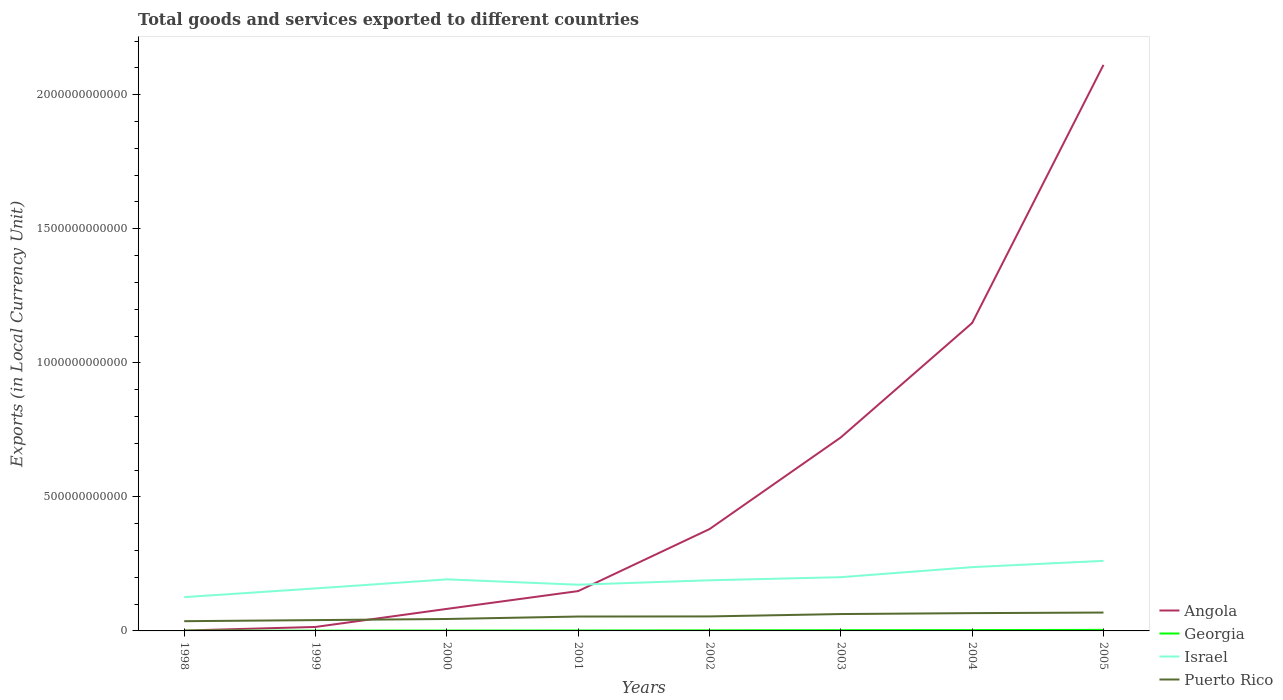Does the line corresponding to Georgia intersect with the line corresponding to Angola?
Provide a succinct answer. No. Across all years, what is the maximum Amount of goods and services exports in Israel?
Your answer should be very brief. 1.26e+11. In which year was the Amount of goods and services exports in Israel maximum?
Keep it short and to the point. 1998. What is the total Amount of goods and services exports in Angola in the graph?
Your response must be concise. -1.13e+12. What is the difference between the highest and the second highest Amount of goods and services exports in Georgia?
Make the answer very short. 3.10e+09. Is the Amount of goods and services exports in Georgia strictly greater than the Amount of goods and services exports in Israel over the years?
Give a very brief answer. Yes. What is the difference between two consecutive major ticks on the Y-axis?
Your answer should be very brief. 5.00e+11. Are the values on the major ticks of Y-axis written in scientific E-notation?
Give a very brief answer. No. Where does the legend appear in the graph?
Provide a short and direct response. Bottom right. What is the title of the graph?
Your answer should be very brief. Total goods and services exported to different countries. Does "Mexico" appear as one of the legend labels in the graph?
Provide a succinct answer. No. What is the label or title of the X-axis?
Offer a terse response. Years. What is the label or title of the Y-axis?
Offer a very short reply. Exports (in Local Currency Unit). What is the Exports (in Local Currency Unit) in Angola in 1998?
Provide a succinct answer. 1.44e+09. What is the Exports (in Local Currency Unit) of Georgia in 1998?
Ensure brevity in your answer.  8.27e+08. What is the Exports (in Local Currency Unit) of Israel in 1998?
Make the answer very short. 1.26e+11. What is the Exports (in Local Currency Unit) of Puerto Rico in 1998?
Offer a terse response. 3.63e+1. What is the Exports (in Local Currency Unit) of Angola in 1999?
Your response must be concise. 1.48e+1. What is the Exports (in Local Currency Unit) in Georgia in 1999?
Keep it short and to the point. 1.08e+09. What is the Exports (in Local Currency Unit) of Israel in 1999?
Make the answer very short. 1.59e+11. What is the Exports (in Local Currency Unit) in Puerto Rico in 1999?
Offer a terse response. 4.03e+1. What is the Exports (in Local Currency Unit) of Angola in 2000?
Provide a short and direct response. 8.22e+1. What is the Exports (in Local Currency Unit) of Georgia in 2000?
Ensure brevity in your answer.  1.39e+09. What is the Exports (in Local Currency Unit) of Israel in 2000?
Your answer should be very brief. 1.92e+11. What is the Exports (in Local Currency Unit) of Puerto Rico in 2000?
Ensure brevity in your answer.  4.45e+1. What is the Exports (in Local Currency Unit) of Angola in 2001?
Your answer should be very brief. 1.49e+11. What is the Exports (in Local Currency Unit) of Georgia in 2001?
Your answer should be compact. 1.63e+09. What is the Exports (in Local Currency Unit) in Israel in 2001?
Provide a short and direct response. 1.72e+11. What is the Exports (in Local Currency Unit) of Puerto Rico in 2001?
Provide a short and direct response. 5.37e+1. What is the Exports (in Local Currency Unit) in Angola in 2002?
Ensure brevity in your answer.  3.80e+11. What is the Exports (in Local Currency Unit) of Georgia in 2002?
Provide a short and direct response. 2.18e+09. What is the Exports (in Local Currency Unit) of Israel in 2002?
Give a very brief answer. 1.89e+11. What is the Exports (in Local Currency Unit) of Puerto Rico in 2002?
Offer a terse response. 5.41e+1. What is the Exports (in Local Currency Unit) in Angola in 2003?
Provide a succinct answer. 7.22e+11. What is the Exports (in Local Currency Unit) in Georgia in 2003?
Your answer should be compact. 2.73e+09. What is the Exports (in Local Currency Unit) in Israel in 2003?
Your answer should be very brief. 2.00e+11. What is the Exports (in Local Currency Unit) of Puerto Rico in 2003?
Offer a very short reply. 6.30e+1. What is the Exports (in Local Currency Unit) of Angola in 2004?
Provide a succinct answer. 1.15e+12. What is the Exports (in Local Currency Unit) of Georgia in 2004?
Keep it short and to the point. 3.10e+09. What is the Exports (in Local Currency Unit) in Israel in 2004?
Ensure brevity in your answer.  2.38e+11. What is the Exports (in Local Currency Unit) in Puerto Rico in 2004?
Keep it short and to the point. 6.64e+1. What is the Exports (in Local Currency Unit) in Angola in 2005?
Provide a short and direct response. 2.11e+12. What is the Exports (in Local Currency Unit) in Georgia in 2005?
Keep it short and to the point. 3.92e+09. What is the Exports (in Local Currency Unit) in Israel in 2005?
Offer a terse response. 2.61e+11. What is the Exports (in Local Currency Unit) in Puerto Rico in 2005?
Give a very brief answer. 6.86e+1. Across all years, what is the maximum Exports (in Local Currency Unit) of Angola?
Keep it short and to the point. 2.11e+12. Across all years, what is the maximum Exports (in Local Currency Unit) in Georgia?
Ensure brevity in your answer.  3.92e+09. Across all years, what is the maximum Exports (in Local Currency Unit) in Israel?
Your response must be concise. 2.61e+11. Across all years, what is the maximum Exports (in Local Currency Unit) of Puerto Rico?
Make the answer very short. 6.86e+1. Across all years, what is the minimum Exports (in Local Currency Unit) in Angola?
Ensure brevity in your answer.  1.44e+09. Across all years, what is the minimum Exports (in Local Currency Unit) in Georgia?
Provide a succinct answer. 8.27e+08. Across all years, what is the minimum Exports (in Local Currency Unit) in Israel?
Your answer should be very brief. 1.26e+11. Across all years, what is the minimum Exports (in Local Currency Unit) of Puerto Rico?
Offer a very short reply. 3.63e+1. What is the total Exports (in Local Currency Unit) of Angola in the graph?
Make the answer very short. 4.61e+12. What is the total Exports (in Local Currency Unit) of Georgia in the graph?
Offer a terse response. 1.69e+1. What is the total Exports (in Local Currency Unit) in Israel in the graph?
Give a very brief answer. 1.54e+12. What is the total Exports (in Local Currency Unit) of Puerto Rico in the graph?
Make the answer very short. 4.27e+11. What is the difference between the Exports (in Local Currency Unit) in Angola in 1998 and that in 1999?
Offer a very short reply. -1.34e+1. What is the difference between the Exports (in Local Currency Unit) in Georgia in 1998 and that in 1999?
Provide a short and direct response. -2.54e+08. What is the difference between the Exports (in Local Currency Unit) in Israel in 1998 and that in 1999?
Give a very brief answer. -3.25e+1. What is the difference between the Exports (in Local Currency Unit) in Puerto Rico in 1998 and that in 1999?
Offer a terse response. -4.00e+09. What is the difference between the Exports (in Local Currency Unit) of Angola in 1998 and that in 2000?
Provide a succinct answer. -8.07e+1. What is the difference between the Exports (in Local Currency Unit) in Georgia in 1998 and that in 2000?
Ensure brevity in your answer.  -5.63e+08. What is the difference between the Exports (in Local Currency Unit) of Israel in 1998 and that in 2000?
Ensure brevity in your answer.  -6.62e+1. What is the difference between the Exports (in Local Currency Unit) of Puerto Rico in 1998 and that in 2000?
Provide a short and direct response. -8.22e+09. What is the difference between the Exports (in Local Currency Unit) in Angola in 1998 and that in 2001?
Keep it short and to the point. -1.47e+11. What is the difference between the Exports (in Local Currency Unit) in Georgia in 1998 and that in 2001?
Make the answer very short. -8.06e+08. What is the difference between the Exports (in Local Currency Unit) in Israel in 1998 and that in 2001?
Your answer should be compact. -4.63e+1. What is the difference between the Exports (in Local Currency Unit) in Puerto Rico in 1998 and that in 2001?
Offer a terse response. -1.74e+1. What is the difference between the Exports (in Local Currency Unit) of Angola in 1998 and that in 2002?
Make the answer very short. -3.78e+11. What is the difference between the Exports (in Local Currency Unit) of Georgia in 1998 and that in 2002?
Offer a terse response. -1.35e+09. What is the difference between the Exports (in Local Currency Unit) of Israel in 1998 and that in 2002?
Keep it short and to the point. -6.29e+1. What is the difference between the Exports (in Local Currency Unit) in Puerto Rico in 1998 and that in 2002?
Your response must be concise. -1.78e+1. What is the difference between the Exports (in Local Currency Unit) in Angola in 1998 and that in 2003?
Offer a terse response. -7.20e+11. What is the difference between the Exports (in Local Currency Unit) in Georgia in 1998 and that in 2003?
Ensure brevity in your answer.  -1.90e+09. What is the difference between the Exports (in Local Currency Unit) of Israel in 1998 and that in 2003?
Provide a succinct answer. -7.44e+1. What is the difference between the Exports (in Local Currency Unit) in Puerto Rico in 1998 and that in 2003?
Your answer should be very brief. -2.67e+1. What is the difference between the Exports (in Local Currency Unit) of Angola in 1998 and that in 2004?
Make the answer very short. -1.15e+12. What is the difference between the Exports (in Local Currency Unit) in Georgia in 1998 and that in 2004?
Make the answer very short. -2.27e+09. What is the difference between the Exports (in Local Currency Unit) of Israel in 1998 and that in 2004?
Provide a succinct answer. -1.12e+11. What is the difference between the Exports (in Local Currency Unit) in Puerto Rico in 1998 and that in 2004?
Offer a very short reply. -3.01e+1. What is the difference between the Exports (in Local Currency Unit) of Angola in 1998 and that in 2005?
Your answer should be compact. -2.11e+12. What is the difference between the Exports (in Local Currency Unit) in Georgia in 1998 and that in 2005?
Your answer should be very brief. -3.10e+09. What is the difference between the Exports (in Local Currency Unit) in Israel in 1998 and that in 2005?
Keep it short and to the point. -1.35e+11. What is the difference between the Exports (in Local Currency Unit) in Puerto Rico in 1998 and that in 2005?
Offer a terse response. -3.23e+1. What is the difference between the Exports (in Local Currency Unit) of Angola in 1999 and that in 2000?
Provide a short and direct response. -6.73e+1. What is the difference between the Exports (in Local Currency Unit) in Georgia in 1999 and that in 2000?
Your answer should be compact. -3.09e+08. What is the difference between the Exports (in Local Currency Unit) of Israel in 1999 and that in 2000?
Offer a terse response. -3.37e+1. What is the difference between the Exports (in Local Currency Unit) in Puerto Rico in 1999 and that in 2000?
Give a very brief answer. -4.22e+09. What is the difference between the Exports (in Local Currency Unit) of Angola in 1999 and that in 2001?
Offer a terse response. -1.34e+11. What is the difference between the Exports (in Local Currency Unit) of Georgia in 1999 and that in 2001?
Your answer should be very brief. -5.52e+08. What is the difference between the Exports (in Local Currency Unit) in Israel in 1999 and that in 2001?
Give a very brief answer. -1.38e+1. What is the difference between the Exports (in Local Currency Unit) in Puerto Rico in 1999 and that in 2001?
Make the answer very short. -1.34e+1. What is the difference between the Exports (in Local Currency Unit) of Angola in 1999 and that in 2002?
Offer a terse response. -3.65e+11. What is the difference between the Exports (in Local Currency Unit) of Georgia in 1999 and that in 2002?
Your response must be concise. -1.10e+09. What is the difference between the Exports (in Local Currency Unit) in Israel in 1999 and that in 2002?
Make the answer very short. -3.03e+1. What is the difference between the Exports (in Local Currency Unit) of Puerto Rico in 1999 and that in 2002?
Offer a very short reply. -1.38e+1. What is the difference between the Exports (in Local Currency Unit) of Angola in 1999 and that in 2003?
Ensure brevity in your answer.  -7.07e+11. What is the difference between the Exports (in Local Currency Unit) in Georgia in 1999 and that in 2003?
Ensure brevity in your answer.  -1.65e+09. What is the difference between the Exports (in Local Currency Unit) of Israel in 1999 and that in 2003?
Keep it short and to the point. -4.19e+1. What is the difference between the Exports (in Local Currency Unit) of Puerto Rico in 1999 and that in 2003?
Your response must be concise. -2.27e+1. What is the difference between the Exports (in Local Currency Unit) in Angola in 1999 and that in 2004?
Ensure brevity in your answer.  -1.13e+12. What is the difference between the Exports (in Local Currency Unit) in Georgia in 1999 and that in 2004?
Keep it short and to the point. -2.02e+09. What is the difference between the Exports (in Local Currency Unit) of Israel in 1999 and that in 2004?
Your answer should be compact. -7.94e+1. What is the difference between the Exports (in Local Currency Unit) of Puerto Rico in 1999 and that in 2004?
Offer a very short reply. -2.61e+1. What is the difference between the Exports (in Local Currency Unit) in Angola in 1999 and that in 2005?
Your answer should be compact. -2.10e+12. What is the difference between the Exports (in Local Currency Unit) of Georgia in 1999 and that in 2005?
Offer a very short reply. -2.84e+09. What is the difference between the Exports (in Local Currency Unit) in Israel in 1999 and that in 2005?
Ensure brevity in your answer.  -1.03e+11. What is the difference between the Exports (in Local Currency Unit) of Puerto Rico in 1999 and that in 2005?
Keep it short and to the point. -2.83e+1. What is the difference between the Exports (in Local Currency Unit) in Angola in 2000 and that in 2001?
Give a very brief answer. -6.64e+1. What is the difference between the Exports (in Local Currency Unit) in Georgia in 2000 and that in 2001?
Provide a short and direct response. -2.43e+08. What is the difference between the Exports (in Local Currency Unit) in Israel in 2000 and that in 2001?
Make the answer very short. 1.99e+1. What is the difference between the Exports (in Local Currency Unit) of Puerto Rico in 2000 and that in 2001?
Offer a terse response. -9.18e+09. What is the difference between the Exports (in Local Currency Unit) of Angola in 2000 and that in 2002?
Make the answer very short. -2.98e+11. What is the difference between the Exports (in Local Currency Unit) in Georgia in 2000 and that in 2002?
Your response must be concise. -7.90e+08. What is the difference between the Exports (in Local Currency Unit) in Israel in 2000 and that in 2002?
Your response must be concise. 3.37e+09. What is the difference between the Exports (in Local Currency Unit) in Puerto Rico in 2000 and that in 2002?
Ensure brevity in your answer.  -9.58e+09. What is the difference between the Exports (in Local Currency Unit) of Angola in 2000 and that in 2003?
Make the answer very short. -6.40e+11. What is the difference between the Exports (in Local Currency Unit) in Georgia in 2000 and that in 2003?
Keep it short and to the point. -1.34e+09. What is the difference between the Exports (in Local Currency Unit) in Israel in 2000 and that in 2003?
Make the answer very short. -8.22e+09. What is the difference between the Exports (in Local Currency Unit) in Puerto Rico in 2000 and that in 2003?
Ensure brevity in your answer.  -1.84e+1. What is the difference between the Exports (in Local Currency Unit) of Angola in 2000 and that in 2004?
Your response must be concise. -1.07e+12. What is the difference between the Exports (in Local Currency Unit) of Georgia in 2000 and that in 2004?
Keep it short and to the point. -1.71e+09. What is the difference between the Exports (in Local Currency Unit) of Israel in 2000 and that in 2004?
Your response must be concise. -4.56e+1. What is the difference between the Exports (in Local Currency Unit) of Puerto Rico in 2000 and that in 2004?
Ensure brevity in your answer.  -2.19e+1. What is the difference between the Exports (in Local Currency Unit) of Angola in 2000 and that in 2005?
Provide a short and direct response. -2.03e+12. What is the difference between the Exports (in Local Currency Unit) in Georgia in 2000 and that in 2005?
Your response must be concise. -2.53e+09. What is the difference between the Exports (in Local Currency Unit) of Israel in 2000 and that in 2005?
Offer a terse response. -6.91e+1. What is the difference between the Exports (in Local Currency Unit) in Puerto Rico in 2000 and that in 2005?
Keep it short and to the point. -2.40e+1. What is the difference between the Exports (in Local Currency Unit) in Angola in 2001 and that in 2002?
Make the answer very short. -2.31e+11. What is the difference between the Exports (in Local Currency Unit) in Georgia in 2001 and that in 2002?
Your response must be concise. -5.47e+08. What is the difference between the Exports (in Local Currency Unit) in Israel in 2001 and that in 2002?
Offer a terse response. -1.66e+1. What is the difference between the Exports (in Local Currency Unit) in Puerto Rico in 2001 and that in 2002?
Give a very brief answer. -3.95e+08. What is the difference between the Exports (in Local Currency Unit) in Angola in 2001 and that in 2003?
Make the answer very short. -5.73e+11. What is the difference between the Exports (in Local Currency Unit) of Georgia in 2001 and that in 2003?
Make the answer very short. -1.09e+09. What is the difference between the Exports (in Local Currency Unit) of Israel in 2001 and that in 2003?
Your response must be concise. -2.82e+1. What is the difference between the Exports (in Local Currency Unit) in Puerto Rico in 2001 and that in 2003?
Offer a terse response. -9.26e+09. What is the difference between the Exports (in Local Currency Unit) in Angola in 2001 and that in 2004?
Provide a short and direct response. -1.00e+12. What is the difference between the Exports (in Local Currency Unit) in Georgia in 2001 and that in 2004?
Provide a succinct answer. -1.47e+09. What is the difference between the Exports (in Local Currency Unit) of Israel in 2001 and that in 2004?
Offer a very short reply. -6.56e+1. What is the difference between the Exports (in Local Currency Unit) of Puerto Rico in 2001 and that in 2004?
Give a very brief answer. -1.27e+1. What is the difference between the Exports (in Local Currency Unit) of Angola in 2001 and that in 2005?
Ensure brevity in your answer.  -1.96e+12. What is the difference between the Exports (in Local Currency Unit) in Georgia in 2001 and that in 2005?
Make the answer very short. -2.29e+09. What is the difference between the Exports (in Local Currency Unit) of Israel in 2001 and that in 2005?
Provide a short and direct response. -8.90e+1. What is the difference between the Exports (in Local Currency Unit) of Puerto Rico in 2001 and that in 2005?
Offer a very short reply. -1.49e+1. What is the difference between the Exports (in Local Currency Unit) in Angola in 2002 and that in 2003?
Provide a short and direct response. -3.42e+11. What is the difference between the Exports (in Local Currency Unit) in Georgia in 2002 and that in 2003?
Ensure brevity in your answer.  -5.47e+08. What is the difference between the Exports (in Local Currency Unit) in Israel in 2002 and that in 2003?
Make the answer very short. -1.16e+1. What is the difference between the Exports (in Local Currency Unit) of Puerto Rico in 2002 and that in 2003?
Your answer should be very brief. -8.87e+09. What is the difference between the Exports (in Local Currency Unit) in Angola in 2002 and that in 2004?
Your answer should be compact. -7.69e+11. What is the difference between the Exports (in Local Currency Unit) in Georgia in 2002 and that in 2004?
Keep it short and to the point. -9.21e+08. What is the difference between the Exports (in Local Currency Unit) of Israel in 2002 and that in 2004?
Keep it short and to the point. -4.90e+1. What is the difference between the Exports (in Local Currency Unit) in Puerto Rico in 2002 and that in 2004?
Your response must be concise. -1.23e+1. What is the difference between the Exports (in Local Currency Unit) of Angola in 2002 and that in 2005?
Give a very brief answer. -1.73e+12. What is the difference between the Exports (in Local Currency Unit) of Georgia in 2002 and that in 2005?
Offer a terse response. -1.74e+09. What is the difference between the Exports (in Local Currency Unit) of Israel in 2002 and that in 2005?
Your answer should be compact. -7.24e+1. What is the difference between the Exports (in Local Currency Unit) in Puerto Rico in 2002 and that in 2005?
Ensure brevity in your answer.  -1.45e+1. What is the difference between the Exports (in Local Currency Unit) of Angola in 2003 and that in 2004?
Offer a terse response. -4.27e+11. What is the difference between the Exports (in Local Currency Unit) in Georgia in 2003 and that in 2004?
Make the answer very short. -3.74e+08. What is the difference between the Exports (in Local Currency Unit) of Israel in 2003 and that in 2004?
Your answer should be compact. -3.74e+1. What is the difference between the Exports (in Local Currency Unit) in Puerto Rico in 2003 and that in 2004?
Keep it short and to the point. -3.43e+09. What is the difference between the Exports (in Local Currency Unit) in Angola in 2003 and that in 2005?
Offer a very short reply. -1.39e+12. What is the difference between the Exports (in Local Currency Unit) in Georgia in 2003 and that in 2005?
Make the answer very short. -1.20e+09. What is the difference between the Exports (in Local Currency Unit) in Israel in 2003 and that in 2005?
Give a very brief answer. -6.09e+1. What is the difference between the Exports (in Local Currency Unit) in Puerto Rico in 2003 and that in 2005?
Keep it short and to the point. -5.59e+09. What is the difference between the Exports (in Local Currency Unit) of Angola in 2004 and that in 2005?
Provide a succinct answer. -9.63e+11. What is the difference between the Exports (in Local Currency Unit) in Georgia in 2004 and that in 2005?
Give a very brief answer. -8.22e+08. What is the difference between the Exports (in Local Currency Unit) in Israel in 2004 and that in 2005?
Offer a very short reply. -2.34e+1. What is the difference between the Exports (in Local Currency Unit) in Puerto Rico in 2004 and that in 2005?
Offer a very short reply. -2.16e+09. What is the difference between the Exports (in Local Currency Unit) in Angola in 1998 and the Exports (in Local Currency Unit) in Georgia in 1999?
Keep it short and to the point. 3.56e+08. What is the difference between the Exports (in Local Currency Unit) in Angola in 1998 and the Exports (in Local Currency Unit) in Israel in 1999?
Provide a short and direct response. -1.57e+11. What is the difference between the Exports (in Local Currency Unit) in Angola in 1998 and the Exports (in Local Currency Unit) in Puerto Rico in 1999?
Offer a very short reply. -3.89e+1. What is the difference between the Exports (in Local Currency Unit) in Georgia in 1998 and the Exports (in Local Currency Unit) in Israel in 1999?
Provide a succinct answer. -1.58e+11. What is the difference between the Exports (in Local Currency Unit) in Georgia in 1998 and the Exports (in Local Currency Unit) in Puerto Rico in 1999?
Offer a terse response. -3.95e+1. What is the difference between the Exports (in Local Currency Unit) of Israel in 1998 and the Exports (in Local Currency Unit) of Puerto Rico in 1999?
Keep it short and to the point. 8.57e+1. What is the difference between the Exports (in Local Currency Unit) of Angola in 1998 and the Exports (in Local Currency Unit) of Georgia in 2000?
Provide a short and direct response. 4.65e+07. What is the difference between the Exports (in Local Currency Unit) of Angola in 1998 and the Exports (in Local Currency Unit) of Israel in 2000?
Provide a short and direct response. -1.91e+11. What is the difference between the Exports (in Local Currency Unit) of Angola in 1998 and the Exports (in Local Currency Unit) of Puerto Rico in 2000?
Make the answer very short. -4.31e+1. What is the difference between the Exports (in Local Currency Unit) of Georgia in 1998 and the Exports (in Local Currency Unit) of Israel in 2000?
Offer a very short reply. -1.91e+11. What is the difference between the Exports (in Local Currency Unit) of Georgia in 1998 and the Exports (in Local Currency Unit) of Puerto Rico in 2000?
Keep it short and to the point. -4.37e+1. What is the difference between the Exports (in Local Currency Unit) in Israel in 1998 and the Exports (in Local Currency Unit) in Puerto Rico in 2000?
Provide a short and direct response. 8.15e+1. What is the difference between the Exports (in Local Currency Unit) of Angola in 1998 and the Exports (in Local Currency Unit) of Georgia in 2001?
Your answer should be very brief. -1.96e+08. What is the difference between the Exports (in Local Currency Unit) of Angola in 1998 and the Exports (in Local Currency Unit) of Israel in 2001?
Keep it short and to the point. -1.71e+11. What is the difference between the Exports (in Local Currency Unit) in Angola in 1998 and the Exports (in Local Currency Unit) in Puerto Rico in 2001?
Your response must be concise. -5.23e+1. What is the difference between the Exports (in Local Currency Unit) of Georgia in 1998 and the Exports (in Local Currency Unit) of Israel in 2001?
Keep it short and to the point. -1.72e+11. What is the difference between the Exports (in Local Currency Unit) in Georgia in 1998 and the Exports (in Local Currency Unit) in Puerto Rico in 2001?
Give a very brief answer. -5.29e+1. What is the difference between the Exports (in Local Currency Unit) in Israel in 1998 and the Exports (in Local Currency Unit) in Puerto Rico in 2001?
Offer a very short reply. 7.23e+1. What is the difference between the Exports (in Local Currency Unit) of Angola in 1998 and the Exports (in Local Currency Unit) of Georgia in 2002?
Your response must be concise. -7.43e+08. What is the difference between the Exports (in Local Currency Unit) in Angola in 1998 and the Exports (in Local Currency Unit) in Israel in 2002?
Offer a terse response. -1.87e+11. What is the difference between the Exports (in Local Currency Unit) in Angola in 1998 and the Exports (in Local Currency Unit) in Puerto Rico in 2002?
Keep it short and to the point. -5.27e+1. What is the difference between the Exports (in Local Currency Unit) of Georgia in 1998 and the Exports (in Local Currency Unit) of Israel in 2002?
Ensure brevity in your answer.  -1.88e+11. What is the difference between the Exports (in Local Currency Unit) in Georgia in 1998 and the Exports (in Local Currency Unit) in Puerto Rico in 2002?
Keep it short and to the point. -5.33e+1. What is the difference between the Exports (in Local Currency Unit) of Israel in 1998 and the Exports (in Local Currency Unit) of Puerto Rico in 2002?
Ensure brevity in your answer.  7.19e+1. What is the difference between the Exports (in Local Currency Unit) of Angola in 1998 and the Exports (in Local Currency Unit) of Georgia in 2003?
Offer a terse response. -1.29e+09. What is the difference between the Exports (in Local Currency Unit) of Angola in 1998 and the Exports (in Local Currency Unit) of Israel in 2003?
Keep it short and to the point. -1.99e+11. What is the difference between the Exports (in Local Currency Unit) of Angola in 1998 and the Exports (in Local Currency Unit) of Puerto Rico in 2003?
Your answer should be very brief. -6.15e+1. What is the difference between the Exports (in Local Currency Unit) of Georgia in 1998 and the Exports (in Local Currency Unit) of Israel in 2003?
Ensure brevity in your answer.  -2.00e+11. What is the difference between the Exports (in Local Currency Unit) of Georgia in 1998 and the Exports (in Local Currency Unit) of Puerto Rico in 2003?
Your answer should be very brief. -6.21e+1. What is the difference between the Exports (in Local Currency Unit) in Israel in 1998 and the Exports (in Local Currency Unit) in Puerto Rico in 2003?
Offer a very short reply. 6.31e+1. What is the difference between the Exports (in Local Currency Unit) in Angola in 1998 and the Exports (in Local Currency Unit) in Georgia in 2004?
Offer a very short reply. -1.66e+09. What is the difference between the Exports (in Local Currency Unit) of Angola in 1998 and the Exports (in Local Currency Unit) of Israel in 2004?
Give a very brief answer. -2.36e+11. What is the difference between the Exports (in Local Currency Unit) in Angola in 1998 and the Exports (in Local Currency Unit) in Puerto Rico in 2004?
Your response must be concise. -6.50e+1. What is the difference between the Exports (in Local Currency Unit) in Georgia in 1998 and the Exports (in Local Currency Unit) in Israel in 2004?
Offer a terse response. -2.37e+11. What is the difference between the Exports (in Local Currency Unit) in Georgia in 1998 and the Exports (in Local Currency Unit) in Puerto Rico in 2004?
Give a very brief answer. -6.56e+1. What is the difference between the Exports (in Local Currency Unit) in Israel in 1998 and the Exports (in Local Currency Unit) in Puerto Rico in 2004?
Provide a succinct answer. 5.96e+1. What is the difference between the Exports (in Local Currency Unit) of Angola in 1998 and the Exports (in Local Currency Unit) of Georgia in 2005?
Give a very brief answer. -2.49e+09. What is the difference between the Exports (in Local Currency Unit) in Angola in 1998 and the Exports (in Local Currency Unit) in Israel in 2005?
Provide a short and direct response. -2.60e+11. What is the difference between the Exports (in Local Currency Unit) in Angola in 1998 and the Exports (in Local Currency Unit) in Puerto Rico in 2005?
Offer a terse response. -6.71e+1. What is the difference between the Exports (in Local Currency Unit) in Georgia in 1998 and the Exports (in Local Currency Unit) in Israel in 2005?
Your response must be concise. -2.61e+11. What is the difference between the Exports (in Local Currency Unit) in Georgia in 1998 and the Exports (in Local Currency Unit) in Puerto Rico in 2005?
Keep it short and to the point. -6.77e+1. What is the difference between the Exports (in Local Currency Unit) of Israel in 1998 and the Exports (in Local Currency Unit) of Puerto Rico in 2005?
Offer a terse response. 5.75e+1. What is the difference between the Exports (in Local Currency Unit) of Angola in 1999 and the Exports (in Local Currency Unit) of Georgia in 2000?
Your answer should be very brief. 1.34e+1. What is the difference between the Exports (in Local Currency Unit) of Angola in 1999 and the Exports (in Local Currency Unit) of Israel in 2000?
Provide a succinct answer. -1.77e+11. What is the difference between the Exports (in Local Currency Unit) of Angola in 1999 and the Exports (in Local Currency Unit) of Puerto Rico in 2000?
Make the answer very short. -2.97e+1. What is the difference between the Exports (in Local Currency Unit) in Georgia in 1999 and the Exports (in Local Currency Unit) in Israel in 2000?
Keep it short and to the point. -1.91e+11. What is the difference between the Exports (in Local Currency Unit) of Georgia in 1999 and the Exports (in Local Currency Unit) of Puerto Rico in 2000?
Offer a terse response. -4.34e+1. What is the difference between the Exports (in Local Currency Unit) of Israel in 1999 and the Exports (in Local Currency Unit) of Puerto Rico in 2000?
Give a very brief answer. 1.14e+11. What is the difference between the Exports (in Local Currency Unit) of Angola in 1999 and the Exports (in Local Currency Unit) of Georgia in 2001?
Your answer should be compact. 1.32e+1. What is the difference between the Exports (in Local Currency Unit) in Angola in 1999 and the Exports (in Local Currency Unit) in Israel in 2001?
Give a very brief answer. -1.58e+11. What is the difference between the Exports (in Local Currency Unit) of Angola in 1999 and the Exports (in Local Currency Unit) of Puerto Rico in 2001?
Give a very brief answer. -3.89e+1. What is the difference between the Exports (in Local Currency Unit) of Georgia in 1999 and the Exports (in Local Currency Unit) of Israel in 2001?
Your answer should be compact. -1.71e+11. What is the difference between the Exports (in Local Currency Unit) of Georgia in 1999 and the Exports (in Local Currency Unit) of Puerto Rico in 2001?
Your response must be concise. -5.26e+1. What is the difference between the Exports (in Local Currency Unit) in Israel in 1999 and the Exports (in Local Currency Unit) in Puerto Rico in 2001?
Offer a terse response. 1.05e+11. What is the difference between the Exports (in Local Currency Unit) of Angola in 1999 and the Exports (in Local Currency Unit) of Georgia in 2002?
Offer a very short reply. 1.26e+1. What is the difference between the Exports (in Local Currency Unit) in Angola in 1999 and the Exports (in Local Currency Unit) in Israel in 2002?
Your answer should be compact. -1.74e+11. What is the difference between the Exports (in Local Currency Unit) of Angola in 1999 and the Exports (in Local Currency Unit) of Puerto Rico in 2002?
Provide a succinct answer. -3.93e+1. What is the difference between the Exports (in Local Currency Unit) of Georgia in 1999 and the Exports (in Local Currency Unit) of Israel in 2002?
Give a very brief answer. -1.88e+11. What is the difference between the Exports (in Local Currency Unit) in Georgia in 1999 and the Exports (in Local Currency Unit) in Puerto Rico in 2002?
Offer a very short reply. -5.30e+1. What is the difference between the Exports (in Local Currency Unit) in Israel in 1999 and the Exports (in Local Currency Unit) in Puerto Rico in 2002?
Provide a succinct answer. 1.04e+11. What is the difference between the Exports (in Local Currency Unit) of Angola in 1999 and the Exports (in Local Currency Unit) of Georgia in 2003?
Keep it short and to the point. 1.21e+1. What is the difference between the Exports (in Local Currency Unit) in Angola in 1999 and the Exports (in Local Currency Unit) in Israel in 2003?
Give a very brief answer. -1.86e+11. What is the difference between the Exports (in Local Currency Unit) in Angola in 1999 and the Exports (in Local Currency Unit) in Puerto Rico in 2003?
Make the answer very short. -4.81e+1. What is the difference between the Exports (in Local Currency Unit) in Georgia in 1999 and the Exports (in Local Currency Unit) in Israel in 2003?
Ensure brevity in your answer.  -1.99e+11. What is the difference between the Exports (in Local Currency Unit) in Georgia in 1999 and the Exports (in Local Currency Unit) in Puerto Rico in 2003?
Your answer should be very brief. -6.19e+1. What is the difference between the Exports (in Local Currency Unit) in Israel in 1999 and the Exports (in Local Currency Unit) in Puerto Rico in 2003?
Ensure brevity in your answer.  9.56e+1. What is the difference between the Exports (in Local Currency Unit) of Angola in 1999 and the Exports (in Local Currency Unit) of Georgia in 2004?
Provide a succinct answer. 1.17e+1. What is the difference between the Exports (in Local Currency Unit) in Angola in 1999 and the Exports (in Local Currency Unit) in Israel in 2004?
Your answer should be very brief. -2.23e+11. What is the difference between the Exports (in Local Currency Unit) in Angola in 1999 and the Exports (in Local Currency Unit) in Puerto Rico in 2004?
Your answer should be compact. -5.16e+1. What is the difference between the Exports (in Local Currency Unit) in Georgia in 1999 and the Exports (in Local Currency Unit) in Israel in 2004?
Your answer should be compact. -2.37e+11. What is the difference between the Exports (in Local Currency Unit) in Georgia in 1999 and the Exports (in Local Currency Unit) in Puerto Rico in 2004?
Provide a succinct answer. -6.53e+1. What is the difference between the Exports (in Local Currency Unit) of Israel in 1999 and the Exports (in Local Currency Unit) of Puerto Rico in 2004?
Ensure brevity in your answer.  9.22e+1. What is the difference between the Exports (in Local Currency Unit) of Angola in 1999 and the Exports (in Local Currency Unit) of Georgia in 2005?
Give a very brief answer. 1.09e+1. What is the difference between the Exports (in Local Currency Unit) of Angola in 1999 and the Exports (in Local Currency Unit) of Israel in 2005?
Your answer should be compact. -2.47e+11. What is the difference between the Exports (in Local Currency Unit) of Angola in 1999 and the Exports (in Local Currency Unit) of Puerto Rico in 2005?
Your answer should be compact. -5.37e+1. What is the difference between the Exports (in Local Currency Unit) of Georgia in 1999 and the Exports (in Local Currency Unit) of Israel in 2005?
Your answer should be compact. -2.60e+11. What is the difference between the Exports (in Local Currency Unit) of Georgia in 1999 and the Exports (in Local Currency Unit) of Puerto Rico in 2005?
Offer a terse response. -6.75e+1. What is the difference between the Exports (in Local Currency Unit) of Israel in 1999 and the Exports (in Local Currency Unit) of Puerto Rico in 2005?
Ensure brevity in your answer.  9.00e+1. What is the difference between the Exports (in Local Currency Unit) of Angola in 2000 and the Exports (in Local Currency Unit) of Georgia in 2001?
Provide a short and direct response. 8.05e+1. What is the difference between the Exports (in Local Currency Unit) in Angola in 2000 and the Exports (in Local Currency Unit) in Israel in 2001?
Keep it short and to the point. -9.02e+1. What is the difference between the Exports (in Local Currency Unit) of Angola in 2000 and the Exports (in Local Currency Unit) of Puerto Rico in 2001?
Ensure brevity in your answer.  2.85e+1. What is the difference between the Exports (in Local Currency Unit) of Georgia in 2000 and the Exports (in Local Currency Unit) of Israel in 2001?
Your response must be concise. -1.71e+11. What is the difference between the Exports (in Local Currency Unit) of Georgia in 2000 and the Exports (in Local Currency Unit) of Puerto Rico in 2001?
Ensure brevity in your answer.  -5.23e+1. What is the difference between the Exports (in Local Currency Unit) in Israel in 2000 and the Exports (in Local Currency Unit) in Puerto Rico in 2001?
Your answer should be very brief. 1.39e+11. What is the difference between the Exports (in Local Currency Unit) in Angola in 2000 and the Exports (in Local Currency Unit) in Georgia in 2002?
Ensure brevity in your answer.  8.00e+1. What is the difference between the Exports (in Local Currency Unit) in Angola in 2000 and the Exports (in Local Currency Unit) in Israel in 2002?
Make the answer very short. -1.07e+11. What is the difference between the Exports (in Local Currency Unit) in Angola in 2000 and the Exports (in Local Currency Unit) in Puerto Rico in 2002?
Offer a very short reply. 2.81e+1. What is the difference between the Exports (in Local Currency Unit) in Georgia in 2000 and the Exports (in Local Currency Unit) in Israel in 2002?
Offer a terse response. -1.88e+11. What is the difference between the Exports (in Local Currency Unit) of Georgia in 2000 and the Exports (in Local Currency Unit) of Puerto Rico in 2002?
Keep it short and to the point. -5.27e+1. What is the difference between the Exports (in Local Currency Unit) of Israel in 2000 and the Exports (in Local Currency Unit) of Puerto Rico in 2002?
Keep it short and to the point. 1.38e+11. What is the difference between the Exports (in Local Currency Unit) in Angola in 2000 and the Exports (in Local Currency Unit) in Georgia in 2003?
Provide a short and direct response. 7.94e+1. What is the difference between the Exports (in Local Currency Unit) in Angola in 2000 and the Exports (in Local Currency Unit) in Israel in 2003?
Your answer should be very brief. -1.18e+11. What is the difference between the Exports (in Local Currency Unit) of Angola in 2000 and the Exports (in Local Currency Unit) of Puerto Rico in 2003?
Offer a very short reply. 1.92e+1. What is the difference between the Exports (in Local Currency Unit) of Georgia in 2000 and the Exports (in Local Currency Unit) of Israel in 2003?
Offer a terse response. -1.99e+11. What is the difference between the Exports (in Local Currency Unit) in Georgia in 2000 and the Exports (in Local Currency Unit) in Puerto Rico in 2003?
Your answer should be compact. -6.16e+1. What is the difference between the Exports (in Local Currency Unit) in Israel in 2000 and the Exports (in Local Currency Unit) in Puerto Rico in 2003?
Give a very brief answer. 1.29e+11. What is the difference between the Exports (in Local Currency Unit) in Angola in 2000 and the Exports (in Local Currency Unit) in Georgia in 2004?
Offer a terse response. 7.91e+1. What is the difference between the Exports (in Local Currency Unit) in Angola in 2000 and the Exports (in Local Currency Unit) in Israel in 2004?
Provide a succinct answer. -1.56e+11. What is the difference between the Exports (in Local Currency Unit) of Angola in 2000 and the Exports (in Local Currency Unit) of Puerto Rico in 2004?
Provide a short and direct response. 1.58e+1. What is the difference between the Exports (in Local Currency Unit) in Georgia in 2000 and the Exports (in Local Currency Unit) in Israel in 2004?
Your response must be concise. -2.37e+11. What is the difference between the Exports (in Local Currency Unit) in Georgia in 2000 and the Exports (in Local Currency Unit) in Puerto Rico in 2004?
Your answer should be very brief. -6.50e+1. What is the difference between the Exports (in Local Currency Unit) in Israel in 2000 and the Exports (in Local Currency Unit) in Puerto Rico in 2004?
Offer a terse response. 1.26e+11. What is the difference between the Exports (in Local Currency Unit) in Angola in 2000 and the Exports (in Local Currency Unit) in Georgia in 2005?
Offer a terse response. 7.82e+1. What is the difference between the Exports (in Local Currency Unit) in Angola in 2000 and the Exports (in Local Currency Unit) in Israel in 2005?
Your response must be concise. -1.79e+11. What is the difference between the Exports (in Local Currency Unit) of Angola in 2000 and the Exports (in Local Currency Unit) of Puerto Rico in 2005?
Ensure brevity in your answer.  1.36e+1. What is the difference between the Exports (in Local Currency Unit) in Georgia in 2000 and the Exports (in Local Currency Unit) in Israel in 2005?
Offer a very short reply. -2.60e+11. What is the difference between the Exports (in Local Currency Unit) in Georgia in 2000 and the Exports (in Local Currency Unit) in Puerto Rico in 2005?
Your answer should be compact. -6.72e+1. What is the difference between the Exports (in Local Currency Unit) in Israel in 2000 and the Exports (in Local Currency Unit) in Puerto Rico in 2005?
Give a very brief answer. 1.24e+11. What is the difference between the Exports (in Local Currency Unit) in Angola in 2001 and the Exports (in Local Currency Unit) in Georgia in 2002?
Provide a short and direct response. 1.46e+11. What is the difference between the Exports (in Local Currency Unit) in Angola in 2001 and the Exports (in Local Currency Unit) in Israel in 2002?
Provide a short and direct response. -4.03e+1. What is the difference between the Exports (in Local Currency Unit) in Angola in 2001 and the Exports (in Local Currency Unit) in Puerto Rico in 2002?
Give a very brief answer. 9.45e+1. What is the difference between the Exports (in Local Currency Unit) in Georgia in 2001 and the Exports (in Local Currency Unit) in Israel in 2002?
Provide a succinct answer. -1.87e+11. What is the difference between the Exports (in Local Currency Unit) of Georgia in 2001 and the Exports (in Local Currency Unit) of Puerto Rico in 2002?
Make the answer very short. -5.25e+1. What is the difference between the Exports (in Local Currency Unit) of Israel in 2001 and the Exports (in Local Currency Unit) of Puerto Rico in 2002?
Give a very brief answer. 1.18e+11. What is the difference between the Exports (in Local Currency Unit) in Angola in 2001 and the Exports (in Local Currency Unit) in Georgia in 2003?
Offer a very short reply. 1.46e+11. What is the difference between the Exports (in Local Currency Unit) of Angola in 2001 and the Exports (in Local Currency Unit) of Israel in 2003?
Your response must be concise. -5.19e+1. What is the difference between the Exports (in Local Currency Unit) in Angola in 2001 and the Exports (in Local Currency Unit) in Puerto Rico in 2003?
Your answer should be very brief. 8.56e+1. What is the difference between the Exports (in Local Currency Unit) of Georgia in 2001 and the Exports (in Local Currency Unit) of Israel in 2003?
Your response must be concise. -1.99e+11. What is the difference between the Exports (in Local Currency Unit) of Georgia in 2001 and the Exports (in Local Currency Unit) of Puerto Rico in 2003?
Make the answer very short. -6.13e+1. What is the difference between the Exports (in Local Currency Unit) in Israel in 2001 and the Exports (in Local Currency Unit) in Puerto Rico in 2003?
Offer a terse response. 1.09e+11. What is the difference between the Exports (in Local Currency Unit) in Angola in 2001 and the Exports (in Local Currency Unit) in Georgia in 2004?
Your answer should be very brief. 1.45e+11. What is the difference between the Exports (in Local Currency Unit) of Angola in 2001 and the Exports (in Local Currency Unit) of Israel in 2004?
Offer a terse response. -8.93e+1. What is the difference between the Exports (in Local Currency Unit) in Angola in 2001 and the Exports (in Local Currency Unit) in Puerto Rico in 2004?
Offer a very short reply. 8.22e+1. What is the difference between the Exports (in Local Currency Unit) of Georgia in 2001 and the Exports (in Local Currency Unit) of Israel in 2004?
Give a very brief answer. -2.36e+11. What is the difference between the Exports (in Local Currency Unit) of Georgia in 2001 and the Exports (in Local Currency Unit) of Puerto Rico in 2004?
Make the answer very short. -6.48e+1. What is the difference between the Exports (in Local Currency Unit) in Israel in 2001 and the Exports (in Local Currency Unit) in Puerto Rico in 2004?
Your response must be concise. 1.06e+11. What is the difference between the Exports (in Local Currency Unit) in Angola in 2001 and the Exports (in Local Currency Unit) in Georgia in 2005?
Your answer should be very brief. 1.45e+11. What is the difference between the Exports (in Local Currency Unit) of Angola in 2001 and the Exports (in Local Currency Unit) of Israel in 2005?
Ensure brevity in your answer.  -1.13e+11. What is the difference between the Exports (in Local Currency Unit) of Angola in 2001 and the Exports (in Local Currency Unit) of Puerto Rico in 2005?
Your response must be concise. 8.00e+1. What is the difference between the Exports (in Local Currency Unit) in Georgia in 2001 and the Exports (in Local Currency Unit) in Israel in 2005?
Provide a short and direct response. -2.60e+11. What is the difference between the Exports (in Local Currency Unit) in Georgia in 2001 and the Exports (in Local Currency Unit) in Puerto Rico in 2005?
Offer a very short reply. -6.69e+1. What is the difference between the Exports (in Local Currency Unit) in Israel in 2001 and the Exports (in Local Currency Unit) in Puerto Rico in 2005?
Your answer should be very brief. 1.04e+11. What is the difference between the Exports (in Local Currency Unit) of Angola in 2002 and the Exports (in Local Currency Unit) of Georgia in 2003?
Ensure brevity in your answer.  3.77e+11. What is the difference between the Exports (in Local Currency Unit) in Angola in 2002 and the Exports (in Local Currency Unit) in Israel in 2003?
Your answer should be very brief. 1.79e+11. What is the difference between the Exports (in Local Currency Unit) in Angola in 2002 and the Exports (in Local Currency Unit) in Puerto Rico in 2003?
Provide a succinct answer. 3.17e+11. What is the difference between the Exports (in Local Currency Unit) in Georgia in 2002 and the Exports (in Local Currency Unit) in Israel in 2003?
Give a very brief answer. -1.98e+11. What is the difference between the Exports (in Local Currency Unit) of Georgia in 2002 and the Exports (in Local Currency Unit) of Puerto Rico in 2003?
Offer a very short reply. -6.08e+1. What is the difference between the Exports (in Local Currency Unit) of Israel in 2002 and the Exports (in Local Currency Unit) of Puerto Rico in 2003?
Your response must be concise. 1.26e+11. What is the difference between the Exports (in Local Currency Unit) of Angola in 2002 and the Exports (in Local Currency Unit) of Georgia in 2004?
Make the answer very short. 3.77e+11. What is the difference between the Exports (in Local Currency Unit) in Angola in 2002 and the Exports (in Local Currency Unit) in Israel in 2004?
Keep it short and to the point. 1.42e+11. What is the difference between the Exports (in Local Currency Unit) in Angola in 2002 and the Exports (in Local Currency Unit) in Puerto Rico in 2004?
Offer a terse response. 3.13e+11. What is the difference between the Exports (in Local Currency Unit) of Georgia in 2002 and the Exports (in Local Currency Unit) of Israel in 2004?
Your answer should be compact. -2.36e+11. What is the difference between the Exports (in Local Currency Unit) of Georgia in 2002 and the Exports (in Local Currency Unit) of Puerto Rico in 2004?
Your answer should be very brief. -6.42e+1. What is the difference between the Exports (in Local Currency Unit) in Israel in 2002 and the Exports (in Local Currency Unit) in Puerto Rico in 2004?
Offer a very short reply. 1.23e+11. What is the difference between the Exports (in Local Currency Unit) in Angola in 2002 and the Exports (in Local Currency Unit) in Georgia in 2005?
Keep it short and to the point. 3.76e+11. What is the difference between the Exports (in Local Currency Unit) of Angola in 2002 and the Exports (in Local Currency Unit) of Israel in 2005?
Provide a succinct answer. 1.18e+11. What is the difference between the Exports (in Local Currency Unit) of Angola in 2002 and the Exports (in Local Currency Unit) of Puerto Rico in 2005?
Your response must be concise. 3.11e+11. What is the difference between the Exports (in Local Currency Unit) in Georgia in 2002 and the Exports (in Local Currency Unit) in Israel in 2005?
Offer a terse response. -2.59e+11. What is the difference between the Exports (in Local Currency Unit) in Georgia in 2002 and the Exports (in Local Currency Unit) in Puerto Rico in 2005?
Ensure brevity in your answer.  -6.64e+1. What is the difference between the Exports (in Local Currency Unit) of Israel in 2002 and the Exports (in Local Currency Unit) of Puerto Rico in 2005?
Make the answer very short. 1.20e+11. What is the difference between the Exports (in Local Currency Unit) in Angola in 2003 and the Exports (in Local Currency Unit) in Georgia in 2004?
Keep it short and to the point. 7.19e+11. What is the difference between the Exports (in Local Currency Unit) of Angola in 2003 and the Exports (in Local Currency Unit) of Israel in 2004?
Offer a terse response. 4.84e+11. What is the difference between the Exports (in Local Currency Unit) of Angola in 2003 and the Exports (in Local Currency Unit) of Puerto Rico in 2004?
Make the answer very short. 6.56e+11. What is the difference between the Exports (in Local Currency Unit) in Georgia in 2003 and the Exports (in Local Currency Unit) in Israel in 2004?
Your answer should be very brief. -2.35e+11. What is the difference between the Exports (in Local Currency Unit) in Georgia in 2003 and the Exports (in Local Currency Unit) in Puerto Rico in 2004?
Make the answer very short. -6.37e+1. What is the difference between the Exports (in Local Currency Unit) in Israel in 2003 and the Exports (in Local Currency Unit) in Puerto Rico in 2004?
Your answer should be very brief. 1.34e+11. What is the difference between the Exports (in Local Currency Unit) of Angola in 2003 and the Exports (in Local Currency Unit) of Georgia in 2005?
Your answer should be very brief. 7.18e+11. What is the difference between the Exports (in Local Currency Unit) in Angola in 2003 and the Exports (in Local Currency Unit) in Israel in 2005?
Your response must be concise. 4.61e+11. What is the difference between the Exports (in Local Currency Unit) in Angola in 2003 and the Exports (in Local Currency Unit) in Puerto Rico in 2005?
Ensure brevity in your answer.  6.53e+11. What is the difference between the Exports (in Local Currency Unit) of Georgia in 2003 and the Exports (in Local Currency Unit) of Israel in 2005?
Provide a succinct answer. -2.59e+11. What is the difference between the Exports (in Local Currency Unit) of Georgia in 2003 and the Exports (in Local Currency Unit) of Puerto Rico in 2005?
Offer a very short reply. -6.58e+1. What is the difference between the Exports (in Local Currency Unit) in Israel in 2003 and the Exports (in Local Currency Unit) in Puerto Rico in 2005?
Offer a terse response. 1.32e+11. What is the difference between the Exports (in Local Currency Unit) in Angola in 2004 and the Exports (in Local Currency Unit) in Georgia in 2005?
Your response must be concise. 1.14e+12. What is the difference between the Exports (in Local Currency Unit) in Angola in 2004 and the Exports (in Local Currency Unit) in Israel in 2005?
Offer a terse response. 8.87e+11. What is the difference between the Exports (in Local Currency Unit) of Angola in 2004 and the Exports (in Local Currency Unit) of Puerto Rico in 2005?
Give a very brief answer. 1.08e+12. What is the difference between the Exports (in Local Currency Unit) in Georgia in 2004 and the Exports (in Local Currency Unit) in Israel in 2005?
Give a very brief answer. -2.58e+11. What is the difference between the Exports (in Local Currency Unit) in Georgia in 2004 and the Exports (in Local Currency Unit) in Puerto Rico in 2005?
Ensure brevity in your answer.  -6.55e+1. What is the difference between the Exports (in Local Currency Unit) in Israel in 2004 and the Exports (in Local Currency Unit) in Puerto Rico in 2005?
Ensure brevity in your answer.  1.69e+11. What is the average Exports (in Local Currency Unit) in Angola per year?
Keep it short and to the point. 5.76e+11. What is the average Exports (in Local Currency Unit) of Georgia per year?
Your response must be concise. 2.11e+09. What is the average Exports (in Local Currency Unit) of Israel per year?
Provide a short and direct response. 1.92e+11. What is the average Exports (in Local Currency Unit) in Puerto Rico per year?
Your answer should be very brief. 5.34e+1. In the year 1998, what is the difference between the Exports (in Local Currency Unit) in Angola and Exports (in Local Currency Unit) in Georgia?
Keep it short and to the point. 6.10e+08. In the year 1998, what is the difference between the Exports (in Local Currency Unit) in Angola and Exports (in Local Currency Unit) in Israel?
Make the answer very short. -1.25e+11. In the year 1998, what is the difference between the Exports (in Local Currency Unit) of Angola and Exports (in Local Currency Unit) of Puerto Rico?
Offer a very short reply. -3.49e+1. In the year 1998, what is the difference between the Exports (in Local Currency Unit) of Georgia and Exports (in Local Currency Unit) of Israel?
Ensure brevity in your answer.  -1.25e+11. In the year 1998, what is the difference between the Exports (in Local Currency Unit) in Georgia and Exports (in Local Currency Unit) in Puerto Rico?
Ensure brevity in your answer.  -3.55e+1. In the year 1998, what is the difference between the Exports (in Local Currency Unit) of Israel and Exports (in Local Currency Unit) of Puerto Rico?
Keep it short and to the point. 8.97e+1. In the year 1999, what is the difference between the Exports (in Local Currency Unit) in Angola and Exports (in Local Currency Unit) in Georgia?
Give a very brief answer. 1.37e+1. In the year 1999, what is the difference between the Exports (in Local Currency Unit) in Angola and Exports (in Local Currency Unit) in Israel?
Provide a short and direct response. -1.44e+11. In the year 1999, what is the difference between the Exports (in Local Currency Unit) in Angola and Exports (in Local Currency Unit) in Puerto Rico?
Your answer should be compact. -2.55e+1. In the year 1999, what is the difference between the Exports (in Local Currency Unit) in Georgia and Exports (in Local Currency Unit) in Israel?
Ensure brevity in your answer.  -1.57e+11. In the year 1999, what is the difference between the Exports (in Local Currency Unit) in Georgia and Exports (in Local Currency Unit) in Puerto Rico?
Your response must be concise. -3.92e+1. In the year 1999, what is the difference between the Exports (in Local Currency Unit) of Israel and Exports (in Local Currency Unit) of Puerto Rico?
Offer a terse response. 1.18e+11. In the year 2000, what is the difference between the Exports (in Local Currency Unit) in Angola and Exports (in Local Currency Unit) in Georgia?
Give a very brief answer. 8.08e+1. In the year 2000, what is the difference between the Exports (in Local Currency Unit) in Angola and Exports (in Local Currency Unit) in Israel?
Make the answer very short. -1.10e+11. In the year 2000, what is the difference between the Exports (in Local Currency Unit) in Angola and Exports (in Local Currency Unit) in Puerto Rico?
Your answer should be very brief. 3.76e+1. In the year 2000, what is the difference between the Exports (in Local Currency Unit) in Georgia and Exports (in Local Currency Unit) in Israel?
Offer a terse response. -1.91e+11. In the year 2000, what is the difference between the Exports (in Local Currency Unit) of Georgia and Exports (in Local Currency Unit) of Puerto Rico?
Provide a short and direct response. -4.31e+1. In the year 2000, what is the difference between the Exports (in Local Currency Unit) in Israel and Exports (in Local Currency Unit) in Puerto Rico?
Give a very brief answer. 1.48e+11. In the year 2001, what is the difference between the Exports (in Local Currency Unit) in Angola and Exports (in Local Currency Unit) in Georgia?
Make the answer very short. 1.47e+11. In the year 2001, what is the difference between the Exports (in Local Currency Unit) in Angola and Exports (in Local Currency Unit) in Israel?
Your response must be concise. -2.37e+1. In the year 2001, what is the difference between the Exports (in Local Currency Unit) of Angola and Exports (in Local Currency Unit) of Puerto Rico?
Your answer should be very brief. 9.49e+1. In the year 2001, what is the difference between the Exports (in Local Currency Unit) of Georgia and Exports (in Local Currency Unit) of Israel?
Provide a short and direct response. -1.71e+11. In the year 2001, what is the difference between the Exports (in Local Currency Unit) of Georgia and Exports (in Local Currency Unit) of Puerto Rico?
Your answer should be compact. -5.21e+1. In the year 2001, what is the difference between the Exports (in Local Currency Unit) of Israel and Exports (in Local Currency Unit) of Puerto Rico?
Ensure brevity in your answer.  1.19e+11. In the year 2002, what is the difference between the Exports (in Local Currency Unit) in Angola and Exports (in Local Currency Unit) in Georgia?
Offer a very short reply. 3.78e+11. In the year 2002, what is the difference between the Exports (in Local Currency Unit) of Angola and Exports (in Local Currency Unit) of Israel?
Provide a succinct answer. 1.91e+11. In the year 2002, what is the difference between the Exports (in Local Currency Unit) of Angola and Exports (in Local Currency Unit) of Puerto Rico?
Ensure brevity in your answer.  3.26e+11. In the year 2002, what is the difference between the Exports (in Local Currency Unit) of Georgia and Exports (in Local Currency Unit) of Israel?
Your answer should be compact. -1.87e+11. In the year 2002, what is the difference between the Exports (in Local Currency Unit) in Georgia and Exports (in Local Currency Unit) in Puerto Rico?
Give a very brief answer. -5.19e+1. In the year 2002, what is the difference between the Exports (in Local Currency Unit) in Israel and Exports (in Local Currency Unit) in Puerto Rico?
Provide a succinct answer. 1.35e+11. In the year 2003, what is the difference between the Exports (in Local Currency Unit) of Angola and Exports (in Local Currency Unit) of Georgia?
Make the answer very short. 7.19e+11. In the year 2003, what is the difference between the Exports (in Local Currency Unit) of Angola and Exports (in Local Currency Unit) of Israel?
Ensure brevity in your answer.  5.21e+11. In the year 2003, what is the difference between the Exports (in Local Currency Unit) in Angola and Exports (in Local Currency Unit) in Puerto Rico?
Your answer should be compact. 6.59e+11. In the year 2003, what is the difference between the Exports (in Local Currency Unit) in Georgia and Exports (in Local Currency Unit) in Israel?
Ensure brevity in your answer.  -1.98e+11. In the year 2003, what is the difference between the Exports (in Local Currency Unit) of Georgia and Exports (in Local Currency Unit) of Puerto Rico?
Make the answer very short. -6.02e+1. In the year 2003, what is the difference between the Exports (in Local Currency Unit) in Israel and Exports (in Local Currency Unit) in Puerto Rico?
Offer a very short reply. 1.38e+11. In the year 2004, what is the difference between the Exports (in Local Currency Unit) in Angola and Exports (in Local Currency Unit) in Georgia?
Your answer should be compact. 1.15e+12. In the year 2004, what is the difference between the Exports (in Local Currency Unit) of Angola and Exports (in Local Currency Unit) of Israel?
Make the answer very short. 9.11e+11. In the year 2004, what is the difference between the Exports (in Local Currency Unit) of Angola and Exports (in Local Currency Unit) of Puerto Rico?
Provide a short and direct response. 1.08e+12. In the year 2004, what is the difference between the Exports (in Local Currency Unit) of Georgia and Exports (in Local Currency Unit) of Israel?
Make the answer very short. -2.35e+11. In the year 2004, what is the difference between the Exports (in Local Currency Unit) in Georgia and Exports (in Local Currency Unit) in Puerto Rico?
Your answer should be very brief. -6.33e+1. In the year 2004, what is the difference between the Exports (in Local Currency Unit) in Israel and Exports (in Local Currency Unit) in Puerto Rico?
Your response must be concise. 1.72e+11. In the year 2005, what is the difference between the Exports (in Local Currency Unit) in Angola and Exports (in Local Currency Unit) in Georgia?
Ensure brevity in your answer.  2.11e+12. In the year 2005, what is the difference between the Exports (in Local Currency Unit) of Angola and Exports (in Local Currency Unit) of Israel?
Make the answer very short. 1.85e+12. In the year 2005, what is the difference between the Exports (in Local Currency Unit) of Angola and Exports (in Local Currency Unit) of Puerto Rico?
Keep it short and to the point. 2.04e+12. In the year 2005, what is the difference between the Exports (in Local Currency Unit) of Georgia and Exports (in Local Currency Unit) of Israel?
Provide a succinct answer. -2.57e+11. In the year 2005, what is the difference between the Exports (in Local Currency Unit) of Georgia and Exports (in Local Currency Unit) of Puerto Rico?
Offer a very short reply. -6.46e+1. In the year 2005, what is the difference between the Exports (in Local Currency Unit) of Israel and Exports (in Local Currency Unit) of Puerto Rico?
Your answer should be compact. 1.93e+11. What is the ratio of the Exports (in Local Currency Unit) in Angola in 1998 to that in 1999?
Offer a very short reply. 0.1. What is the ratio of the Exports (in Local Currency Unit) of Georgia in 1998 to that in 1999?
Make the answer very short. 0.77. What is the ratio of the Exports (in Local Currency Unit) of Israel in 1998 to that in 1999?
Offer a terse response. 0.79. What is the ratio of the Exports (in Local Currency Unit) of Puerto Rico in 1998 to that in 1999?
Give a very brief answer. 0.9. What is the ratio of the Exports (in Local Currency Unit) in Angola in 1998 to that in 2000?
Ensure brevity in your answer.  0.02. What is the ratio of the Exports (in Local Currency Unit) of Georgia in 1998 to that in 2000?
Provide a succinct answer. 0.59. What is the ratio of the Exports (in Local Currency Unit) in Israel in 1998 to that in 2000?
Your answer should be compact. 0.66. What is the ratio of the Exports (in Local Currency Unit) in Puerto Rico in 1998 to that in 2000?
Your answer should be very brief. 0.82. What is the ratio of the Exports (in Local Currency Unit) in Angola in 1998 to that in 2001?
Your answer should be very brief. 0.01. What is the ratio of the Exports (in Local Currency Unit) in Georgia in 1998 to that in 2001?
Offer a very short reply. 0.51. What is the ratio of the Exports (in Local Currency Unit) in Israel in 1998 to that in 2001?
Make the answer very short. 0.73. What is the ratio of the Exports (in Local Currency Unit) of Puerto Rico in 1998 to that in 2001?
Make the answer very short. 0.68. What is the ratio of the Exports (in Local Currency Unit) in Angola in 1998 to that in 2002?
Your answer should be compact. 0. What is the ratio of the Exports (in Local Currency Unit) in Georgia in 1998 to that in 2002?
Your response must be concise. 0.38. What is the ratio of the Exports (in Local Currency Unit) in Israel in 1998 to that in 2002?
Offer a terse response. 0.67. What is the ratio of the Exports (in Local Currency Unit) in Puerto Rico in 1998 to that in 2002?
Provide a short and direct response. 0.67. What is the ratio of the Exports (in Local Currency Unit) of Angola in 1998 to that in 2003?
Your response must be concise. 0. What is the ratio of the Exports (in Local Currency Unit) in Georgia in 1998 to that in 2003?
Make the answer very short. 0.3. What is the ratio of the Exports (in Local Currency Unit) in Israel in 1998 to that in 2003?
Your answer should be compact. 0.63. What is the ratio of the Exports (in Local Currency Unit) of Puerto Rico in 1998 to that in 2003?
Your answer should be very brief. 0.58. What is the ratio of the Exports (in Local Currency Unit) in Angola in 1998 to that in 2004?
Make the answer very short. 0. What is the ratio of the Exports (in Local Currency Unit) in Georgia in 1998 to that in 2004?
Provide a succinct answer. 0.27. What is the ratio of the Exports (in Local Currency Unit) of Israel in 1998 to that in 2004?
Provide a short and direct response. 0.53. What is the ratio of the Exports (in Local Currency Unit) in Puerto Rico in 1998 to that in 2004?
Offer a terse response. 0.55. What is the ratio of the Exports (in Local Currency Unit) in Angola in 1998 to that in 2005?
Your answer should be compact. 0. What is the ratio of the Exports (in Local Currency Unit) of Georgia in 1998 to that in 2005?
Ensure brevity in your answer.  0.21. What is the ratio of the Exports (in Local Currency Unit) in Israel in 1998 to that in 2005?
Provide a succinct answer. 0.48. What is the ratio of the Exports (in Local Currency Unit) in Puerto Rico in 1998 to that in 2005?
Give a very brief answer. 0.53. What is the ratio of the Exports (in Local Currency Unit) of Angola in 1999 to that in 2000?
Offer a terse response. 0.18. What is the ratio of the Exports (in Local Currency Unit) in Georgia in 1999 to that in 2000?
Offer a terse response. 0.78. What is the ratio of the Exports (in Local Currency Unit) in Israel in 1999 to that in 2000?
Provide a succinct answer. 0.82. What is the ratio of the Exports (in Local Currency Unit) of Puerto Rico in 1999 to that in 2000?
Provide a succinct answer. 0.91. What is the ratio of the Exports (in Local Currency Unit) in Angola in 1999 to that in 2001?
Your answer should be compact. 0.1. What is the ratio of the Exports (in Local Currency Unit) in Georgia in 1999 to that in 2001?
Offer a very short reply. 0.66. What is the ratio of the Exports (in Local Currency Unit) of Israel in 1999 to that in 2001?
Your answer should be compact. 0.92. What is the ratio of the Exports (in Local Currency Unit) in Puerto Rico in 1999 to that in 2001?
Offer a terse response. 0.75. What is the ratio of the Exports (in Local Currency Unit) of Angola in 1999 to that in 2002?
Provide a succinct answer. 0.04. What is the ratio of the Exports (in Local Currency Unit) in Georgia in 1999 to that in 2002?
Keep it short and to the point. 0.5. What is the ratio of the Exports (in Local Currency Unit) in Israel in 1999 to that in 2002?
Give a very brief answer. 0.84. What is the ratio of the Exports (in Local Currency Unit) in Puerto Rico in 1999 to that in 2002?
Provide a succinct answer. 0.74. What is the ratio of the Exports (in Local Currency Unit) of Angola in 1999 to that in 2003?
Ensure brevity in your answer.  0.02. What is the ratio of the Exports (in Local Currency Unit) in Georgia in 1999 to that in 2003?
Provide a short and direct response. 0.4. What is the ratio of the Exports (in Local Currency Unit) of Israel in 1999 to that in 2003?
Your response must be concise. 0.79. What is the ratio of the Exports (in Local Currency Unit) in Puerto Rico in 1999 to that in 2003?
Provide a succinct answer. 0.64. What is the ratio of the Exports (in Local Currency Unit) in Angola in 1999 to that in 2004?
Offer a terse response. 0.01. What is the ratio of the Exports (in Local Currency Unit) in Georgia in 1999 to that in 2004?
Give a very brief answer. 0.35. What is the ratio of the Exports (in Local Currency Unit) in Israel in 1999 to that in 2004?
Ensure brevity in your answer.  0.67. What is the ratio of the Exports (in Local Currency Unit) of Puerto Rico in 1999 to that in 2004?
Your answer should be very brief. 0.61. What is the ratio of the Exports (in Local Currency Unit) of Angola in 1999 to that in 2005?
Your response must be concise. 0.01. What is the ratio of the Exports (in Local Currency Unit) of Georgia in 1999 to that in 2005?
Ensure brevity in your answer.  0.28. What is the ratio of the Exports (in Local Currency Unit) of Israel in 1999 to that in 2005?
Keep it short and to the point. 0.61. What is the ratio of the Exports (in Local Currency Unit) of Puerto Rico in 1999 to that in 2005?
Your response must be concise. 0.59. What is the ratio of the Exports (in Local Currency Unit) in Angola in 2000 to that in 2001?
Your answer should be very brief. 0.55. What is the ratio of the Exports (in Local Currency Unit) of Georgia in 2000 to that in 2001?
Your response must be concise. 0.85. What is the ratio of the Exports (in Local Currency Unit) of Israel in 2000 to that in 2001?
Offer a terse response. 1.12. What is the ratio of the Exports (in Local Currency Unit) in Puerto Rico in 2000 to that in 2001?
Make the answer very short. 0.83. What is the ratio of the Exports (in Local Currency Unit) in Angola in 2000 to that in 2002?
Your answer should be compact. 0.22. What is the ratio of the Exports (in Local Currency Unit) in Georgia in 2000 to that in 2002?
Your answer should be compact. 0.64. What is the ratio of the Exports (in Local Currency Unit) of Israel in 2000 to that in 2002?
Provide a succinct answer. 1.02. What is the ratio of the Exports (in Local Currency Unit) in Puerto Rico in 2000 to that in 2002?
Keep it short and to the point. 0.82. What is the ratio of the Exports (in Local Currency Unit) of Angola in 2000 to that in 2003?
Your answer should be very brief. 0.11. What is the ratio of the Exports (in Local Currency Unit) of Georgia in 2000 to that in 2003?
Ensure brevity in your answer.  0.51. What is the ratio of the Exports (in Local Currency Unit) in Israel in 2000 to that in 2003?
Ensure brevity in your answer.  0.96. What is the ratio of the Exports (in Local Currency Unit) in Puerto Rico in 2000 to that in 2003?
Give a very brief answer. 0.71. What is the ratio of the Exports (in Local Currency Unit) of Angola in 2000 to that in 2004?
Give a very brief answer. 0.07. What is the ratio of the Exports (in Local Currency Unit) of Georgia in 2000 to that in 2004?
Keep it short and to the point. 0.45. What is the ratio of the Exports (in Local Currency Unit) in Israel in 2000 to that in 2004?
Provide a succinct answer. 0.81. What is the ratio of the Exports (in Local Currency Unit) of Puerto Rico in 2000 to that in 2004?
Provide a succinct answer. 0.67. What is the ratio of the Exports (in Local Currency Unit) in Angola in 2000 to that in 2005?
Ensure brevity in your answer.  0.04. What is the ratio of the Exports (in Local Currency Unit) of Georgia in 2000 to that in 2005?
Your response must be concise. 0.35. What is the ratio of the Exports (in Local Currency Unit) of Israel in 2000 to that in 2005?
Your answer should be very brief. 0.74. What is the ratio of the Exports (in Local Currency Unit) in Puerto Rico in 2000 to that in 2005?
Your answer should be compact. 0.65. What is the ratio of the Exports (in Local Currency Unit) of Angola in 2001 to that in 2002?
Your answer should be compact. 0.39. What is the ratio of the Exports (in Local Currency Unit) of Georgia in 2001 to that in 2002?
Keep it short and to the point. 0.75. What is the ratio of the Exports (in Local Currency Unit) in Israel in 2001 to that in 2002?
Offer a very short reply. 0.91. What is the ratio of the Exports (in Local Currency Unit) in Angola in 2001 to that in 2003?
Your answer should be very brief. 0.21. What is the ratio of the Exports (in Local Currency Unit) of Georgia in 2001 to that in 2003?
Ensure brevity in your answer.  0.6. What is the ratio of the Exports (in Local Currency Unit) of Israel in 2001 to that in 2003?
Your response must be concise. 0.86. What is the ratio of the Exports (in Local Currency Unit) of Puerto Rico in 2001 to that in 2003?
Make the answer very short. 0.85. What is the ratio of the Exports (in Local Currency Unit) of Angola in 2001 to that in 2004?
Ensure brevity in your answer.  0.13. What is the ratio of the Exports (in Local Currency Unit) of Georgia in 2001 to that in 2004?
Keep it short and to the point. 0.53. What is the ratio of the Exports (in Local Currency Unit) of Israel in 2001 to that in 2004?
Offer a terse response. 0.72. What is the ratio of the Exports (in Local Currency Unit) of Puerto Rico in 2001 to that in 2004?
Make the answer very short. 0.81. What is the ratio of the Exports (in Local Currency Unit) of Angola in 2001 to that in 2005?
Provide a short and direct response. 0.07. What is the ratio of the Exports (in Local Currency Unit) of Georgia in 2001 to that in 2005?
Your answer should be very brief. 0.42. What is the ratio of the Exports (in Local Currency Unit) of Israel in 2001 to that in 2005?
Offer a very short reply. 0.66. What is the ratio of the Exports (in Local Currency Unit) of Puerto Rico in 2001 to that in 2005?
Offer a very short reply. 0.78. What is the ratio of the Exports (in Local Currency Unit) in Angola in 2002 to that in 2003?
Make the answer very short. 0.53. What is the ratio of the Exports (in Local Currency Unit) in Georgia in 2002 to that in 2003?
Your response must be concise. 0.8. What is the ratio of the Exports (in Local Currency Unit) of Israel in 2002 to that in 2003?
Offer a terse response. 0.94. What is the ratio of the Exports (in Local Currency Unit) of Puerto Rico in 2002 to that in 2003?
Your response must be concise. 0.86. What is the ratio of the Exports (in Local Currency Unit) of Angola in 2002 to that in 2004?
Make the answer very short. 0.33. What is the ratio of the Exports (in Local Currency Unit) of Georgia in 2002 to that in 2004?
Your answer should be compact. 0.7. What is the ratio of the Exports (in Local Currency Unit) of Israel in 2002 to that in 2004?
Provide a short and direct response. 0.79. What is the ratio of the Exports (in Local Currency Unit) of Puerto Rico in 2002 to that in 2004?
Your response must be concise. 0.81. What is the ratio of the Exports (in Local Currency Unit) of Angola in 2002 to that in 2005?
Offer a terse response. 0.18. What is the ratio of the Exports (in Local Currency Unit) of Georgia in 2002 to that in 2005?
Your answer should be very brief. 0.56. What is the ratio of the Exports (in Local Currency Unit) of Israel in 2002 to that in 2005?
Your response must be concise. 0.72. What is the ratio of the Exports (in Local Currency Unit) of Puerto Rico in 2002 to that in 2005?
Provide a short and direct response. 0.79. What is the ratio of the Exports (in Local Currency Unit) of Angola in 2003 to that in 2004?
Offer a terse response. 0.63. What is the ratio of the Exports (in Local Currency Unit) of Georgia in 2003 to that in 2004?
Provide a succinct answer. 0.88. What is the ratio of the Exports (in Local Currency Unit) of Israel in 2003 to that in 2004?
Provide a short and direct response. 0.84. What is the ratio of the Exports (in Local Currency Unit) of Puerto Rico in 2003 to that in 2004?
Give a very brief answer. 0.95. What is the ratio of the Exports (in Local Currency Unit) of Angola in 2003 to that in 2005?
Give a very brief answer. 0.34. What is the ratio of the Exports (in Local Currency Unit) in Georgia in 2003 to that in 2005?
Provide a short and direct response. 0.7. What is the ratio of the Exports (in Local Currency Unit) in Israel in 2003 to that in 2005?
Give a very brief answer. 0.77. What is the ratio of the Exports (in Local Currency Unit) in Puerto Rico in 2003 to that in 2005?
Provide a succinct answer. 0.92. What is the ratio of the Exports (in Local Currency Unit) of Angola in 2004 to that in 2005?
Provide a succinct answer. 0.54. What is the ratio of the Exports (in Local Currency Unit) of Georgia in 2004 to that in 2005?
Your answer should be very brief. 0.79. What is the ratio of the Exports (in Local Currency Unit) in Israel in 2004 to that in 2005?
Offer a very short reply. 0.91. What is the ratio of the Exports (in Local Currency Unit) in Puerto Rico in 2004 to that in 2005?
Make the answer very short. 0.97. What is the difference between the highest and the second highest Exports (in Local Currency Unit) in Angola?
Offer a terse response. 9.63e+11. What is the difference between the highest and the second highest Exports (in Local Currency Unit) in Georgia?
Ensure brevity in your answer.  8.22e+08. What is the difference between the highest and the second highest Exports (in Local Currency Unit) of Israel?
Ensure brevity in your answer.  2.34e+1. What is the difference between the highest and the second highest Exports (in Local Currency Unit) in Puerto Rico?
Your response must be concise. 2.16e+09. What is the difference between the highest and the lowest Exports (in Local Currency Unit) of Angola?
Give a very brief answer. 2.11e+12. What is the difference between the highest and the lowest Exports (in Local Currency Unit) of Georgia?
Provide a succinct answer. 3.10e+09. What is the difference between the highest and the lowest Exports (in Local Currency Unit) of Israel?
Give a very brief answer. 1.35e+11. What is the difference between the highest and the lowest Exports (in Local Currency Unit) of Puerto Rico?
Your answer should be very brief. 3.23e+1. 